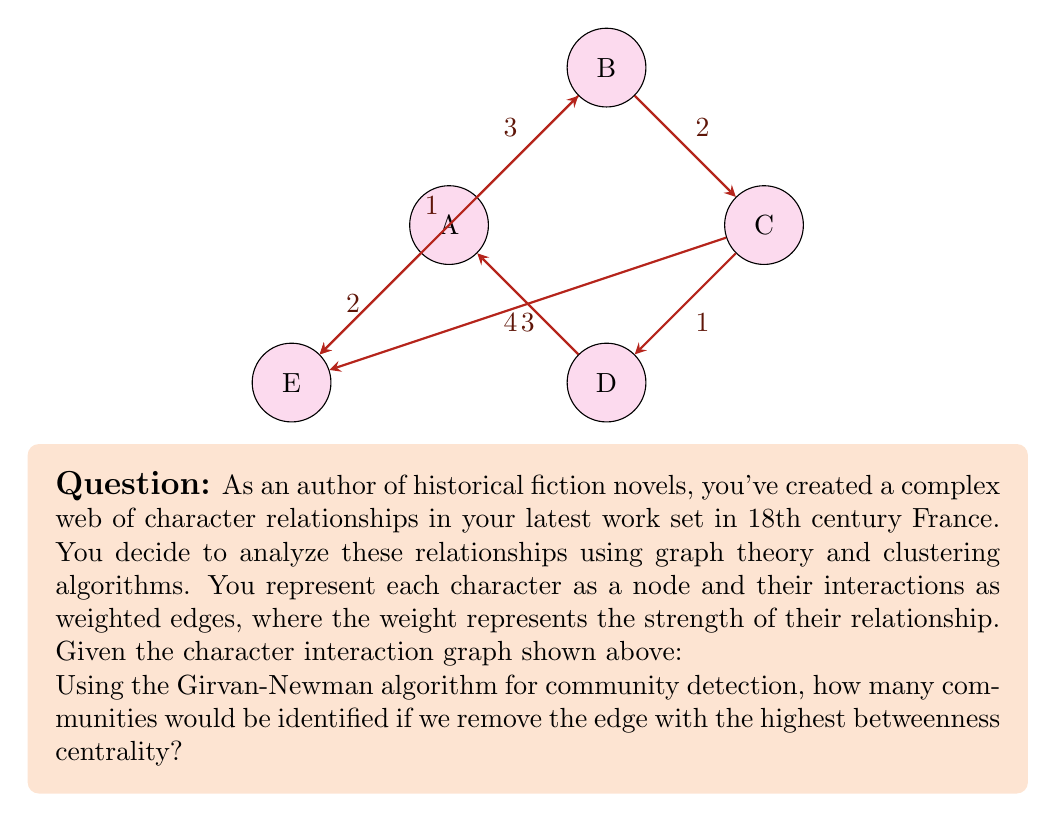Teach me how to tackle this problem. To solve this problem, we'll follow these steps:

1) First, we need to calculate the betweenness centrality of each edge. The betweenness centrality of an edge is the number of shortest paths between all pairs of nodes that pass through that edge.

2) For this small graph, we can do this manually:
   - Edge A-B: 4 paths (E-A-B, E-A-B-C, D-A-B, D-A-B-C)
   - Edge B-C: 3 paths (A-B-C, E-B-C, D-A-B-C)
   - Edge C-D: 1 path (C-D)
   - Edge A-D: 3 paths (B-A-D, E-A-D, C-D-A)
   - Edge A-E: 3 paths (B-A-E, C-E-A, D-A-E)
   - Edge B-E: 1 path (B-E)
   - Edge C-E: 2 paths (A-E-C, D-A-E-C)

3) The edge with the highest betweenness centrality is A-B with 4 paths.

4) If we remove this edge, the graph splits into two components:
   - Component 1: A, D, E
   - Component 2: B, C

5) These components represent the communities in the graph after removing the edge with the highest betweenness centrality.

Therefore, after removing the edge with the highest betweenness centrality (A-B), we would identify 2 communities in the graph.
Answer: 2 communities 